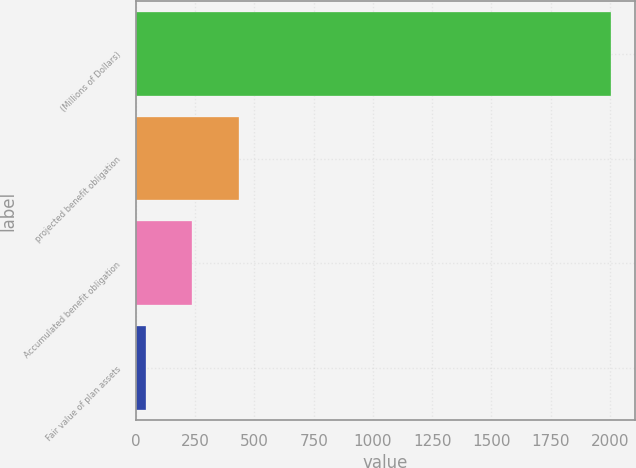Convert chart. <chart><loc_0><loc_0><loc_500><loc_500><bar_chart><fcel>(Millions of Dollars)<fcel>projected benefit obligation<fcel>Accumulated benefit obligation<fcel>Fair value of plan assets<nl><fcel>2005<fcel>434.28<fcel>237.94<fcel>41.6<nl></chart> 